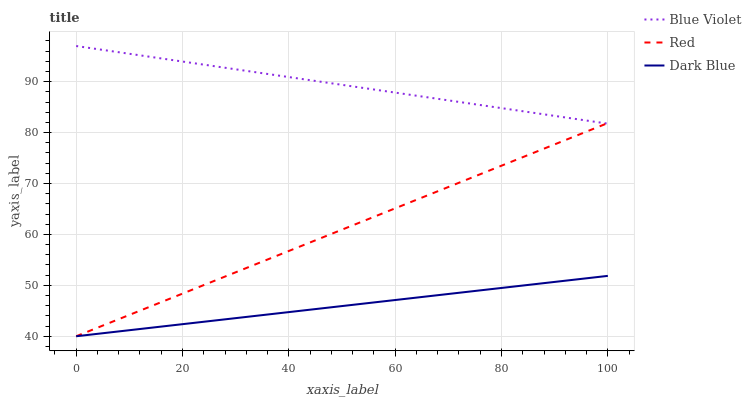Does Dark Blue have the minimum area under the curve?
Answer yes or no. Yes. Does Blue Violet have the maximum area under the curve?
Answer yes or no. Yes. Does Red have the minimum area under the curve?
Answer yes or no. No. Does Red have the maximum area under the curve?
Answer yes or no. No. Is Red the smoothest?
Answer yes or no. Yes. Is Blue Violet the roughest?
Answer yes or no. Yes. Is Blue Violet the smoothest?
Answer yes or no. No. Is Red the roughest?
Answer yes or no. No. Does Dark Blue have the lowest value?
Answer yes or no. Yes. Does Blue Violet have the lowest value?
Answer yes or no. No. Does Blue Violet have the highest value?
Answer yes or no. Yes. Does Red have the highest value?
Answer yes or no. No. Is Dark Blue less than Blue Violet?
Answer yes or no. Yes. Is Blue Violet greater than Dark Blue?
Answer yes or no. Yes. Does Blue Violet intersect Red?
Answer yes or no. Yes. Is Blue Violet less than Red?
Answer yes or no. No. Is Blue Violet greater than Red?
Answer yes or no. No. Does Dark Blue intersect Blue Violet?
Answer yes or no. No. 